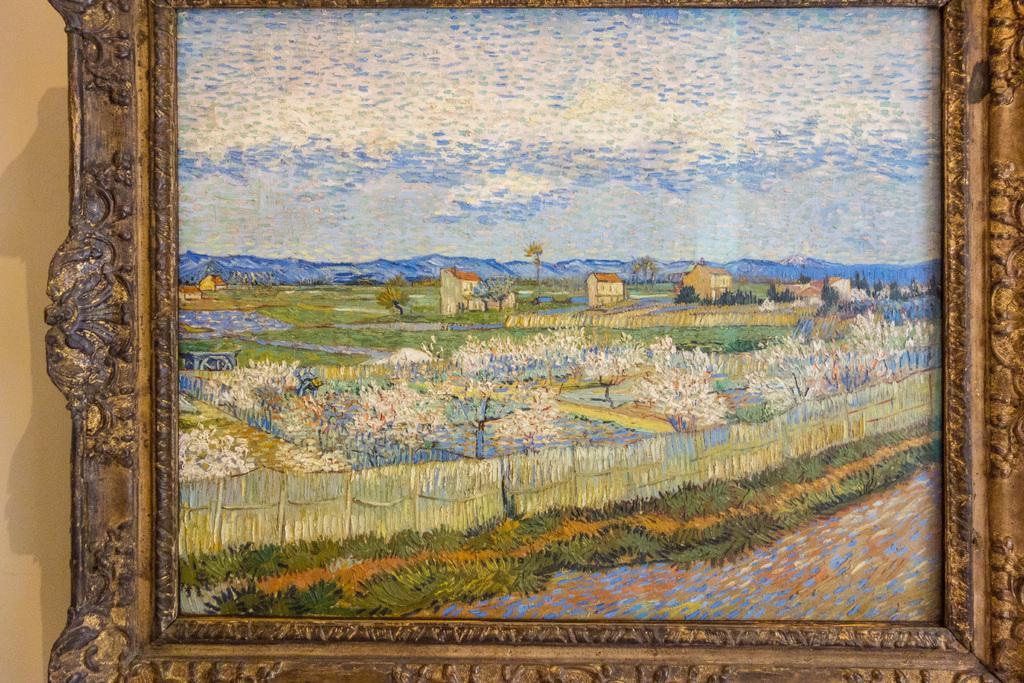Could you give a brief overview of what you see in this image? In this image we can see a wall painting placed on the wall. 